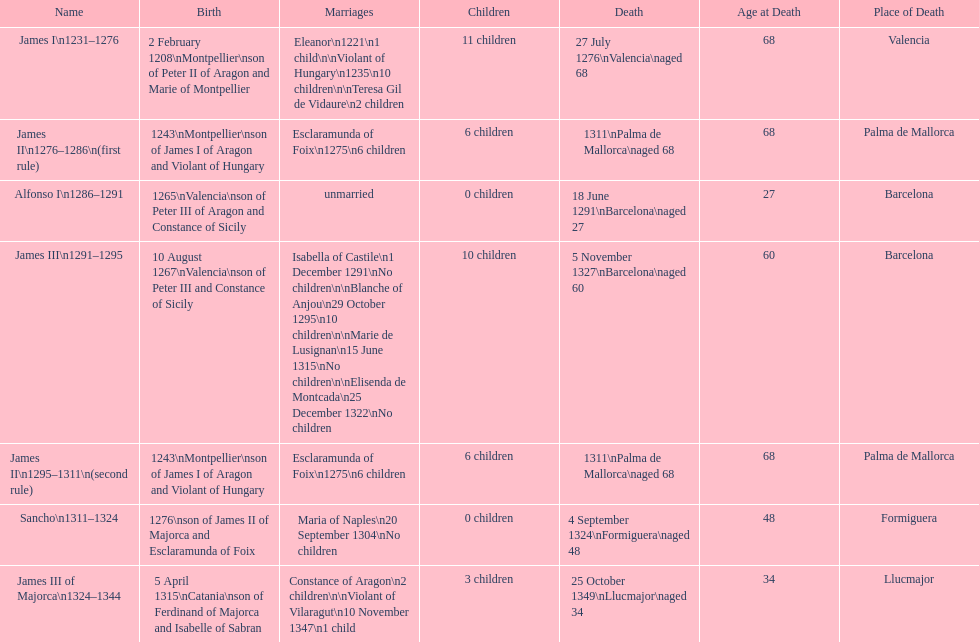Who came to power after the rule of james iii? James II. 